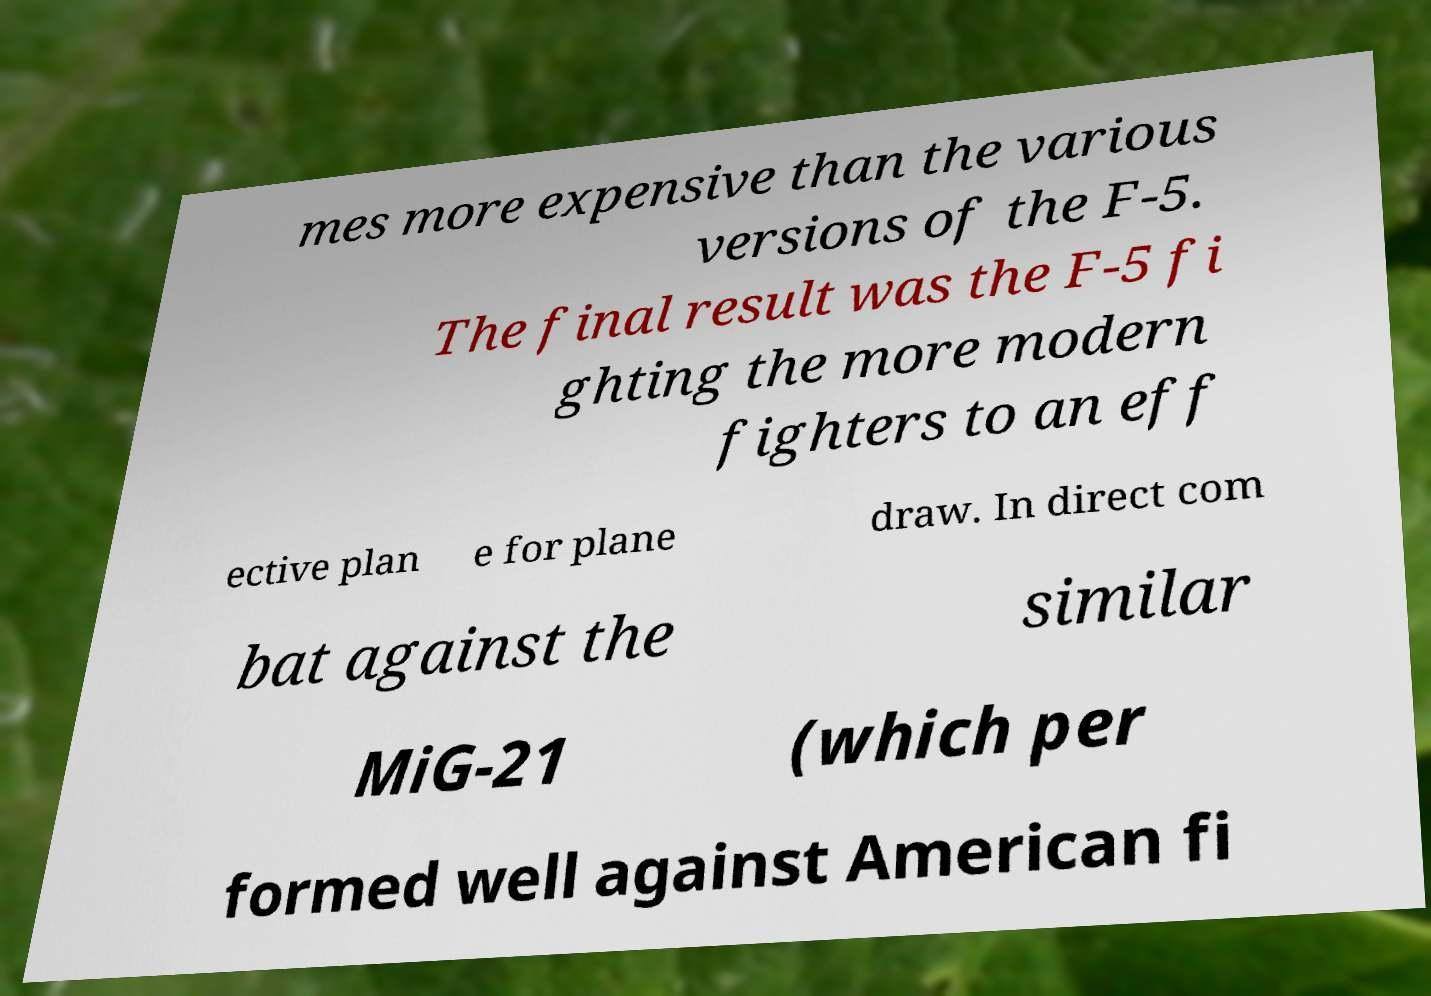There's text embedded in this image that I need extracted. Can you transcribe it verbatim? mes more expensive than the various versions of the F-5. The final result was the F-5 fi ghting the more modern fighters to an eff ective plan e for plane draw. In direct com bat against the similar MiG-21 (which per formed well against American fi 